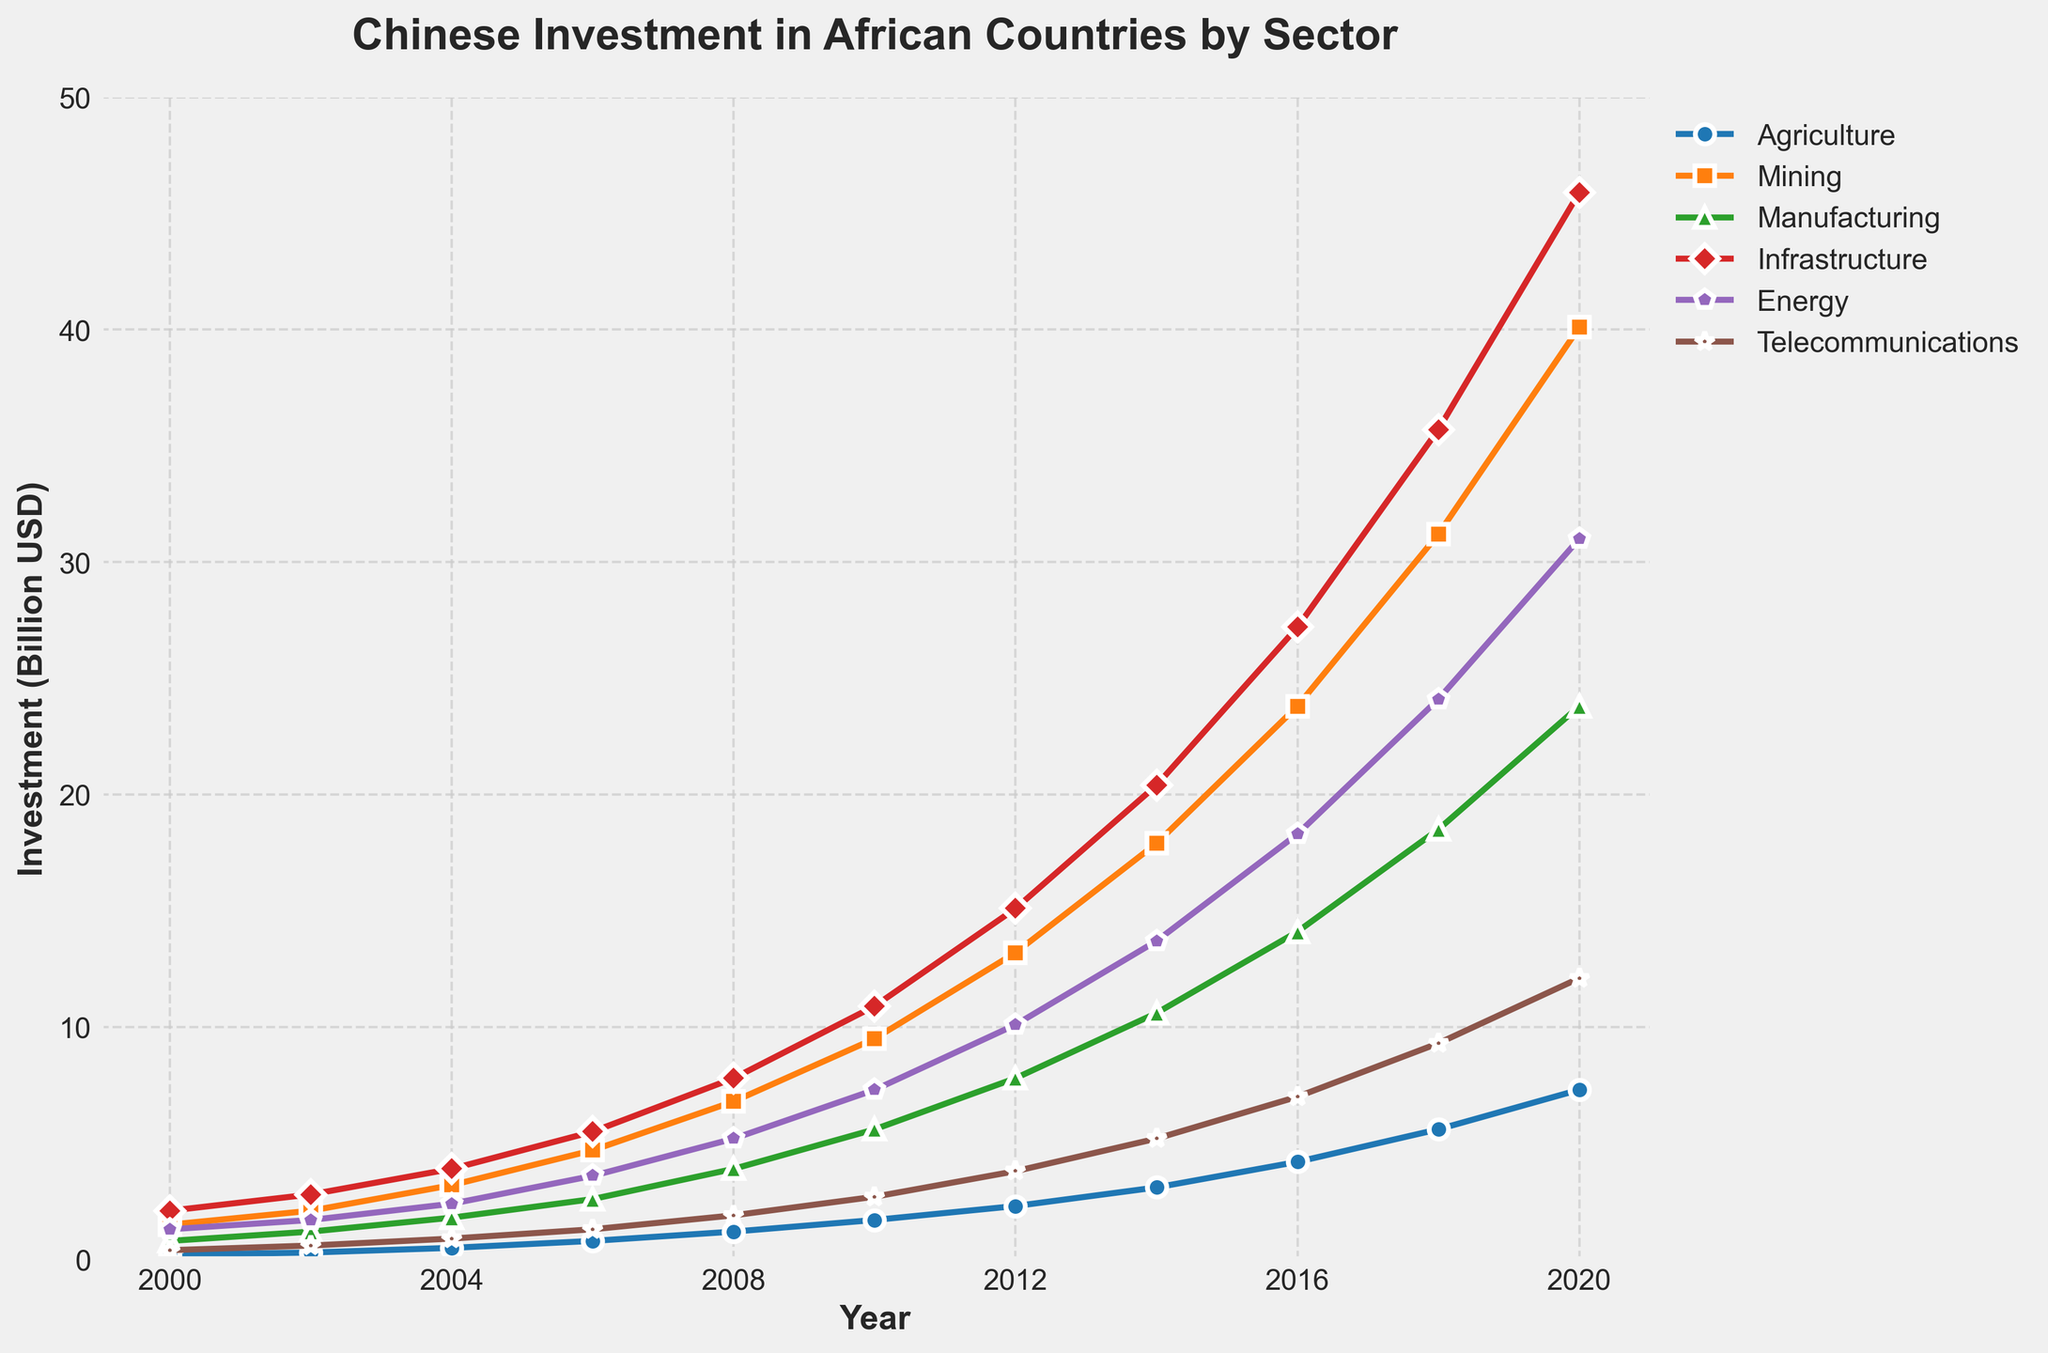What's the sector with the highest investment in 2020? Look at the 2020 data points and compare the values for each sector. Mining has the highest investment value.
Answer: Mining Which sector had the smallest growth from 2000 to 2020? Calculate the difference between the values in 2000 and 2020 for each sector. Telecommunications had the smallest growth, from 0.4 billion to 12.1 billion (11.7 billion).
Answer: Telecommunications How much did the investment in Agriculture increase from 2000 to 2020? Subtract the Agriculture investment in 2000 (0.2 billion) from the investment in 2020 (7.3 billion). The increase is 7.3 - 0.2 = 7.1 billion.
Answer: 7.1 billion In which year did the Manufacturing sector first exceed 10 billion in investment? Identify when the Manufacturing investment value goes above 10 billion. It first occurred in 2014.
Answer: 2014 Between 2010 and 2018, which sector had the highest average annual investment increase? Calculate the annual growth for each sector between 2010 and 2018 by dividing the total increase for each sector by the number of years (8). Mining increased from 9.5 to 31.2 billion (21.7 billion increase over 8 years), averaging 2.71 billion per year, which is the highest.
Answer: Mining Compare the investment in Infrastructure and Energy in 2016; which one was greater? Look at the values for 2016: Infrastructure (27.2 billion) and Energy (18.3 billion). Infrastructure is greater.
Answer: Infrastructure What is the trend in telecommunications investment from 2000 to 2020? Observe the line representing Telecommunications. It shows a steadily increasing trend from 0.4 billion in 2000 to 12.1 billion in 2020.
Answer: Increasing How many sectors had an investment above 20 billion in 2020? Check the 2020 investment values and count the sectors above 20 billion. Infrastructure, Mining, and Energy exceed 20 billion, totaling 3 sectors.
Answer: 3 sectors Which sector had the largest spike in investment between any two consecutive years? Examine the data for the largest increase between consecutive years. The biggest jump is for Mining between 2018 (31.2 billion) and 2020 (40.1 billion), an increase of 8.9 billion.
Answer: Mining 